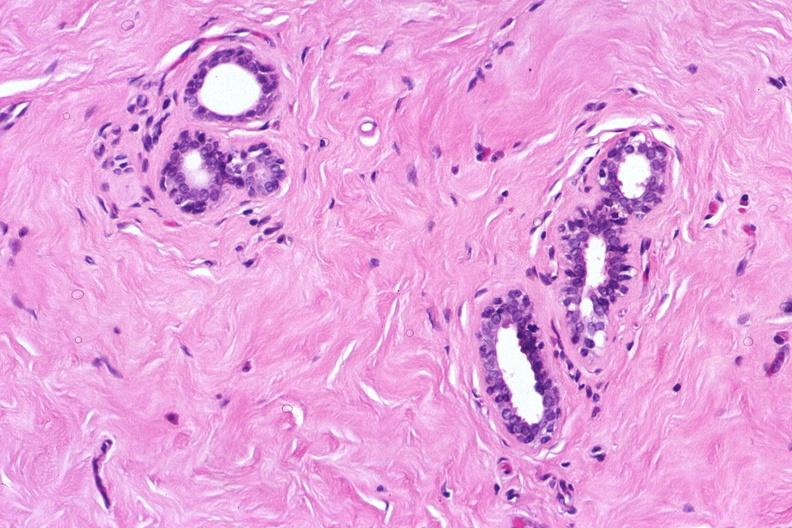what does this image show?
Answer the question using a single word or phrase. Normal breast 